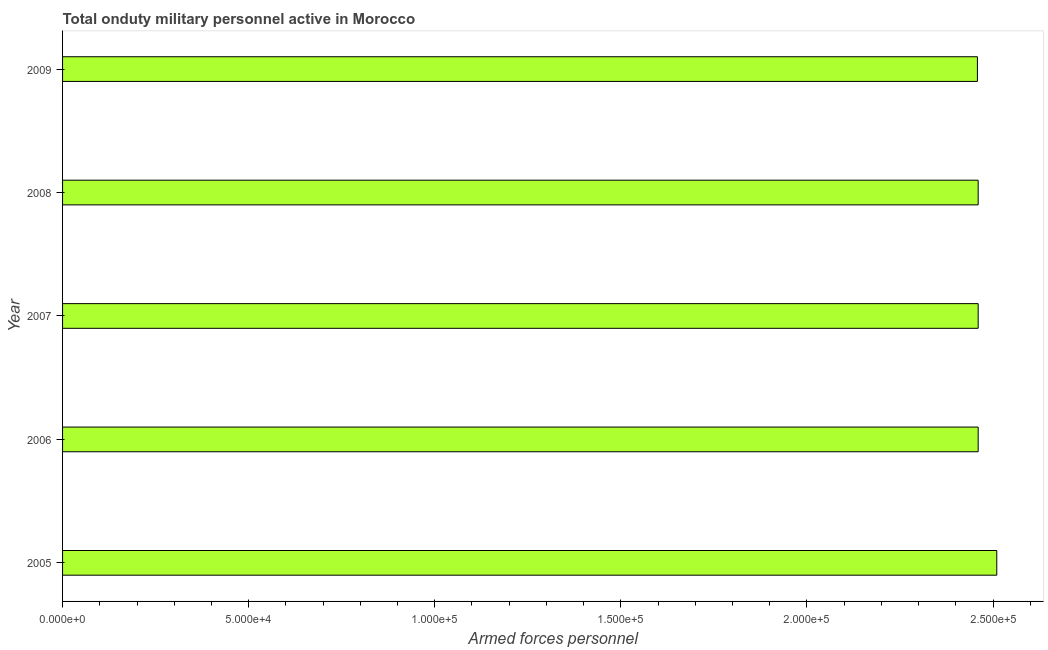Does the graph contain any zero values?
Offer a very short reply. No. What is the title of the graph?
Provide a short and direct response. Total onduty military personnel active in Morocco. What is the label or title of the X-axis?
Offer a very short reply. Armed forces personnel. What is the number of armed forces personnel in 2009?
Ensure brevity in your answer.  2.46e+05. Across all years, what is the maximum number of armed forces personnel?
Give a very brief answer. 2.51e+05. Across all years, what is the minimum number of armed forces personnel?
Provide a short and direct response. 2.46e+05. In which year was the number of armed forces personnel maximum?
Ensure brevity in your answer.  2005. In which year was the number of armed forces personnel minimum?
Your answer should be compact. 2009. What is the sum of the number of armed forces personnel?
Your answer should be compact. 1.23e+06. What is the difference between the number of armed forces personnel in 2007 and 2008?
Make the answer very short. 0. What is the average number of armed forces personnel per year?
Offer a terse response. 2.47e+05. What is the median number of armed forces personnel?
Make the answer very short. 2.46e+05. In how many years, is the number of armed forces personnel greater than 130000 ?
Your response must be concise. 5. Is the number of armed forces personnel in 2007 less than that in 2008?
Keep it short and to the point. No. What is the difference between the highest and the second highest number of armed forces personnel?
Provide a succinct answer. 5000. Is the sum of the number of armed forces personnel in 2008 and 2009 greater than the maximum number of armed forces personnel across all years?
Provide a short and direct response. Yes. What is the difference between the highest and the lowest number of armed forces personnel?
Your answer should be compact. 5200. In how many years, is the number of armed forces personnel greater than the average number of armed forces personnel taken over all years?
Make the answer very short. 1. What is the difference between two consecutive major ticks on the X-axis?
Make the answer very short. 5.00e+04. What is the Armed forces personnel of 2005?
Keep it short and to the point. 2.51e+05. What is the Armed forces personnel in 2006?
Provide a succinct answer. 2.46e+05. What is the Armed forces personnel of 2007?
Ensure brevity in your answer.  2.46e+05. What is the Armed forces personnel in 2008?
Keep it short and to the point. 2.46e+05. What is the Armed forces personnel in 2009?
Offer a very short reply. 2.46e+05. What is the difference between the Armed forces personnel in 2005 and 2008?
Give a very brief answer. 5000. What is the difference between the Armed forces personnel in 2005 and 2009?
Provide a succinct answer. 5200. What is the difference between the Armed forces personnel in 2006 and 2007?
Ensure brevity in your answer.  0. What is the difference between the Armed forces personnel in 2006 and 2008?
Your response must be concise. 0. What is the difference between the Armed forces personnel in 2007 and 2008?
Your response must be concise. 0. What is the difference between the Armed forces personnel in 2007 and 2009?
Offer a very short reply. 200. What is the difference between the Armed forces personnel in 2008 and 2009?
Offer a very short reply. 200. What is the ratio of the Armed forces personnel in 2005 to that in 2006?
Your answer should be compact. 1.02. What is the ratio of the Armed forces personnel in 2006 to that in 2008?
Make the answer very short. 1. 